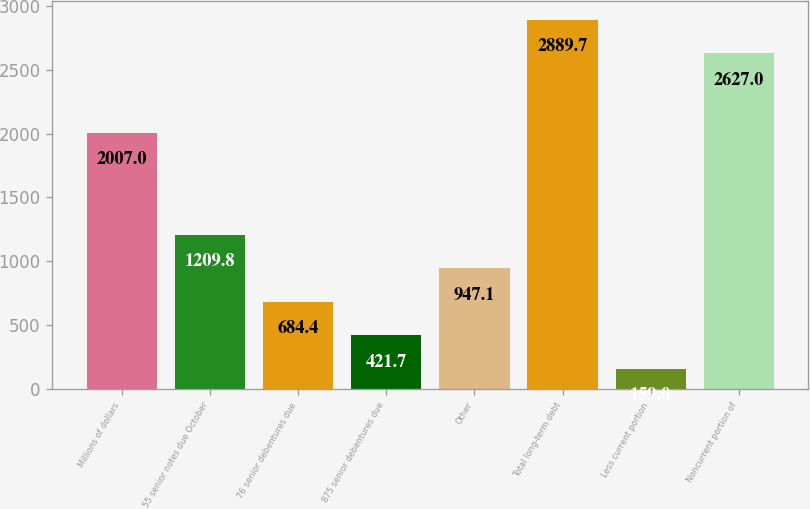Convert chart to OTSL. <chart><loc_0><loc_0><loc_500><loc_500><bar_chart><fcel>Millions of dollars<fcel>55 senior notes due October<fcel>76 senior debentures due<fcel>875 senior debentures due<fcel>Other<fcel>Total long-term debt<fcel>Less current portion<fcel>Noncurrent portion of<nl><fcel>2007<fcel>1209.8<fcel>684.4<fcel>421.7<fcel>947.1<fcel>2889.7<fcel>159<fcel>2627<nl></chart> 